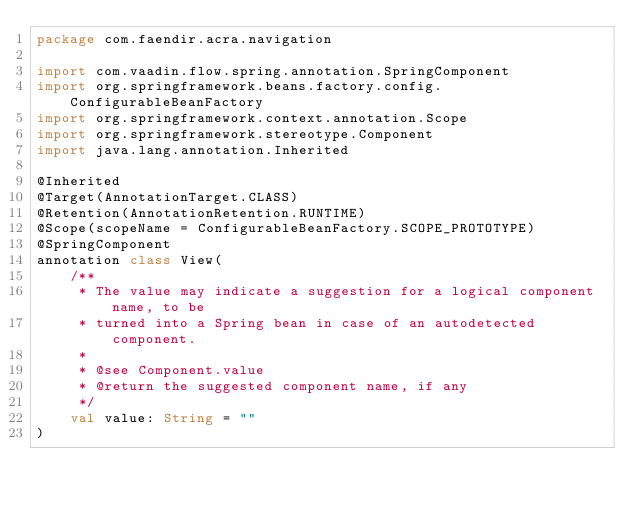<code> <loc_0><loc_0><loc_500><loc_500><_Kotlin_>package com.faendir.acra.navigation

import com.vaadin.flow.spring.annotation.SpringComponent
import org.springframework.beans.factory.config.ConfigurableBeanFactory
import org.springframework.context.annotation.Scope
import org.springframework.stereotype.Component
import java.lang.annotation.Inherited

@Inherited
@Target(AnnotationTarget.CLASS)
@Retention(AnnotationRetention.RUNTIME)
@Scope(scopeName = ConfigurableBeanFactory.SCOPE_PROTOTYPE)
@SpringComponent
annotation class View(
    /**
     * The value may indicate a suggestion for a logical component name, to be
     * turned into a Spring bean in case of an autodetected component.
     *
     * @see Component.value
     * @return the suggested component name, if any
     */
    val value: String = ""
)
</code> 